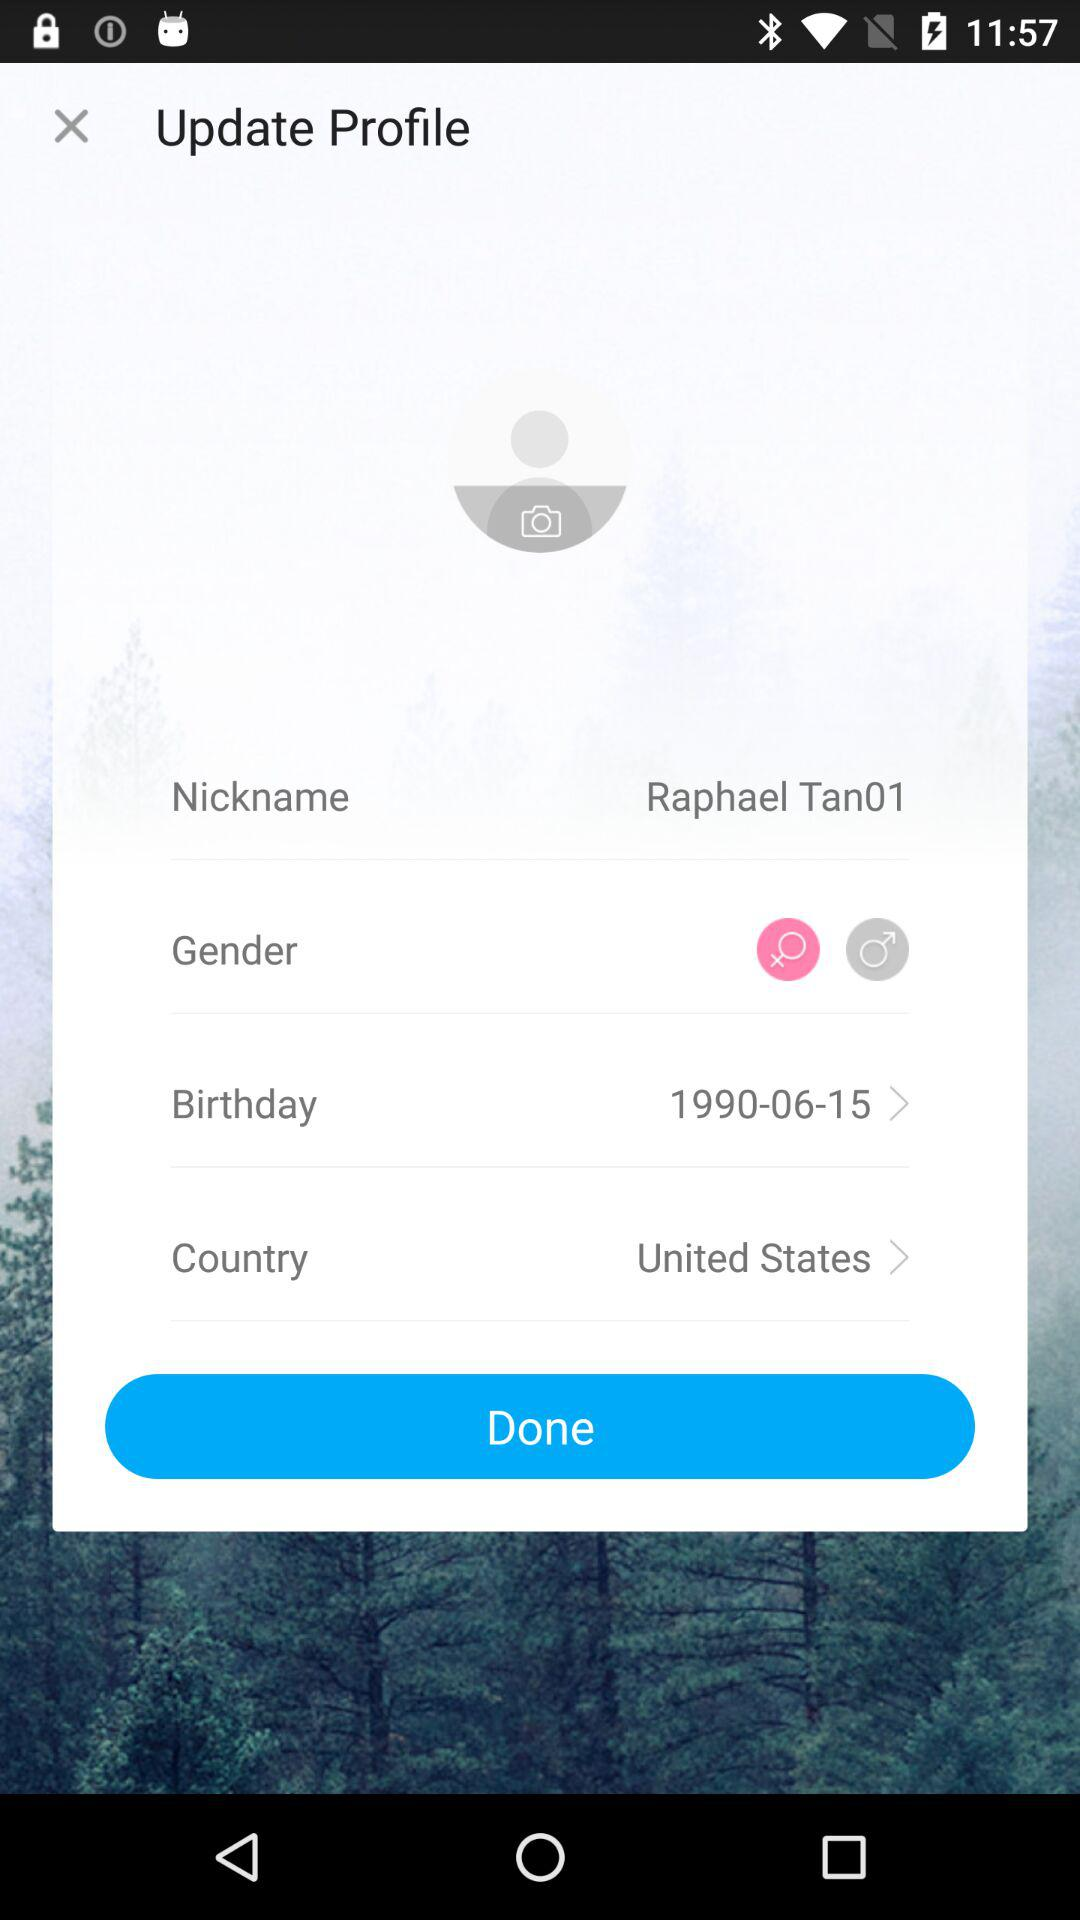What is the country name? The country name is the United States. 